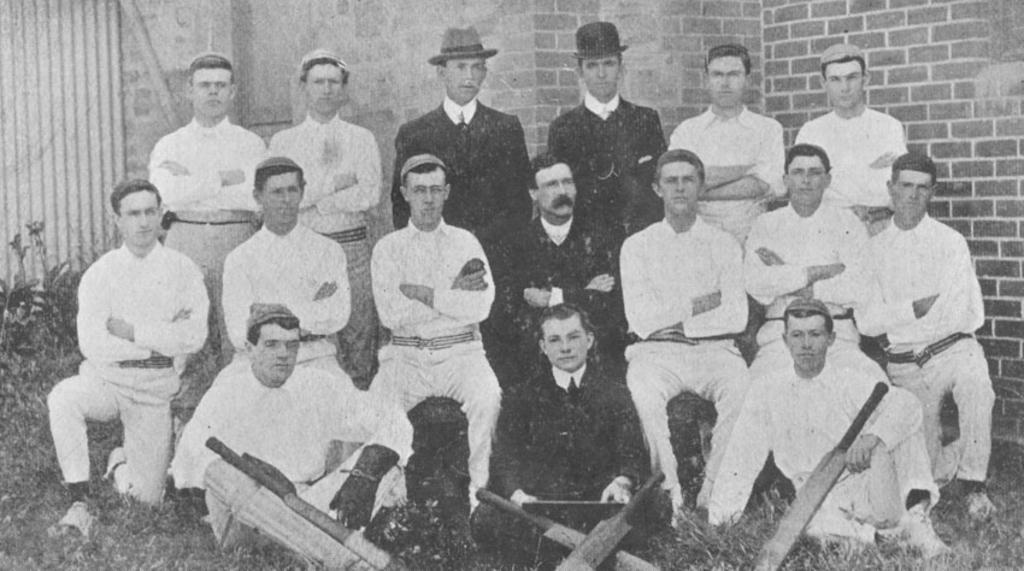How would you summarize this image in a sentence or two? In this image I can see a the black and white picture in which I can see number of persons wearing white colored dresses and few persons wearing black colored dresses are sitting and standing. I can see few cricket bats in front of them. In the background I can see few plants and the wall. 